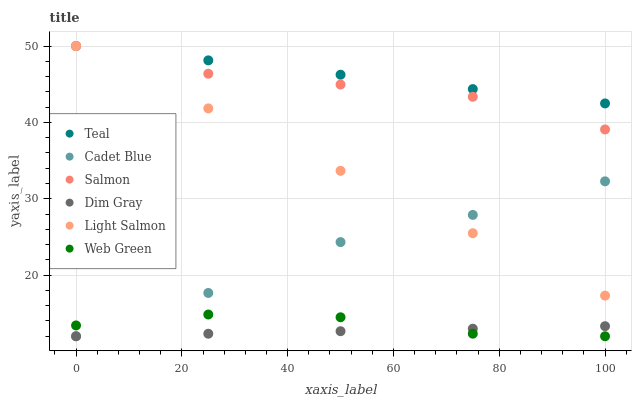Does Dim Gray have the minimum area under the curve?
Answer yes or no. Yes. Does Teal have the maximum area under the curve?
Answer yes or no. Yes. Does Salmon have the minimum area under the curve?
Answer yes or no. No. Does Salmon have the maximum area under the curve?
Answer yes or no. No. Is Light Salmon the smoothest?
Answer yes or no. Yes. Is Web Green the roughest?
Answer yes or no. Yes. Is Dim Gray the smoothest?
Answer yes or no. No. Is Dim Gray the roughest?
Answer yes or no. No. Does Dim Gray have the lowest value?
Answer yes or no. Yes. Does Salmon have the lowest value?
Answer yes or no. No. Does Teal have the highest value?
Answer yes or no. Yes. Does Dim Gray have the highest value?
Answer yes or no. No. Is Web Green less than Teal?
Answer yes or no. Yes. Is Teal greater than Web Green?
Answer yes or no. Yes. Does Light Salmon intersect Salmon?
Answer yes or no. Yes. Is Light Salmon less than Salmon?
Answer yes or no. No. Is Light Salmon greater than Salmon?
Answer yes or no. No. Does Web Green intersect Teal?
Answer yes or no. No. 